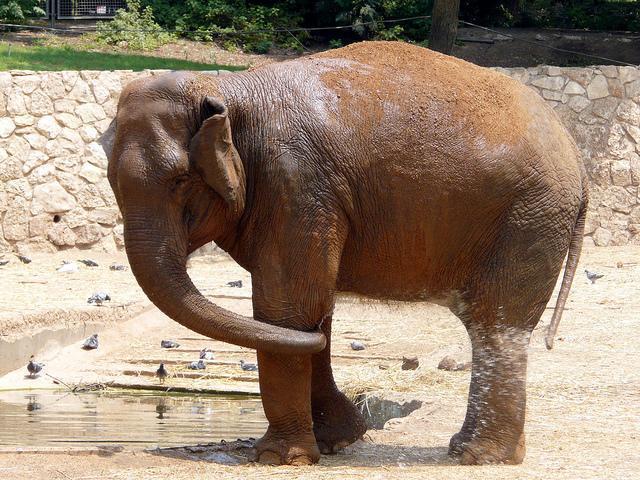Why do hunters hunt this animal?
Choose the correct response, then elucidate: 'Answer: answer
Rationale: rationale.'
Options: Ears, trunk, ivory tusks, tail. Answer: ivory tusks.
Rationale: They want ivory. 